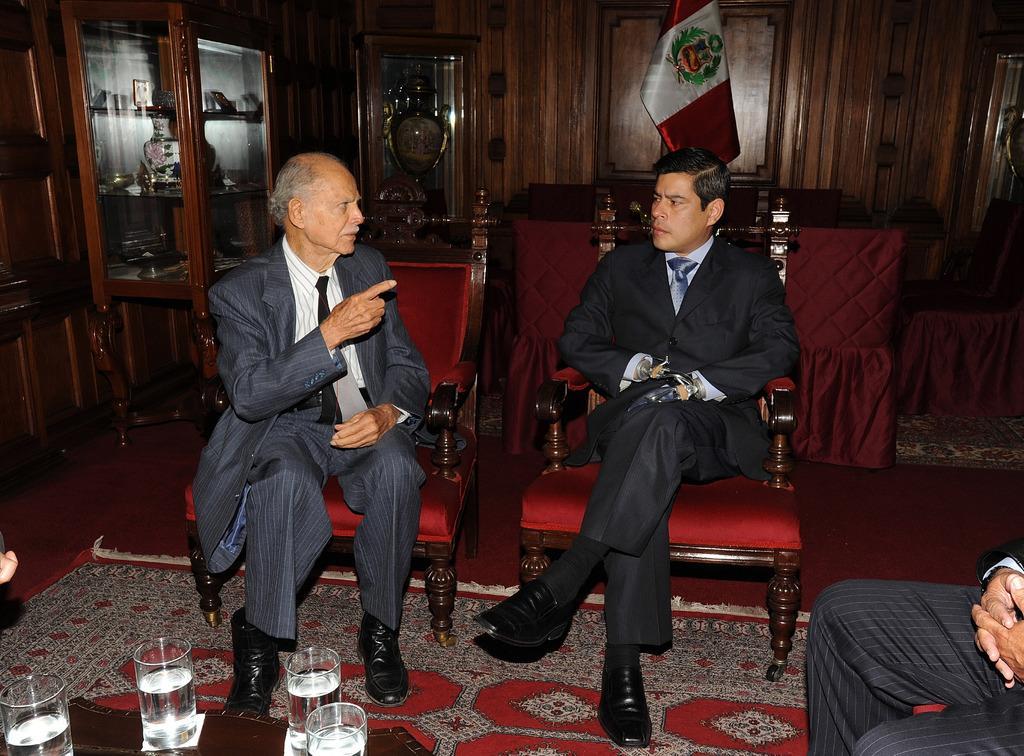Can you describe this image briefly? These persons are sitting on the chairs and this person talking. We can see glasses on the table. On the background we can see wooden wall,flags,furniture,tables,chairs. We can see mat on the floor. 